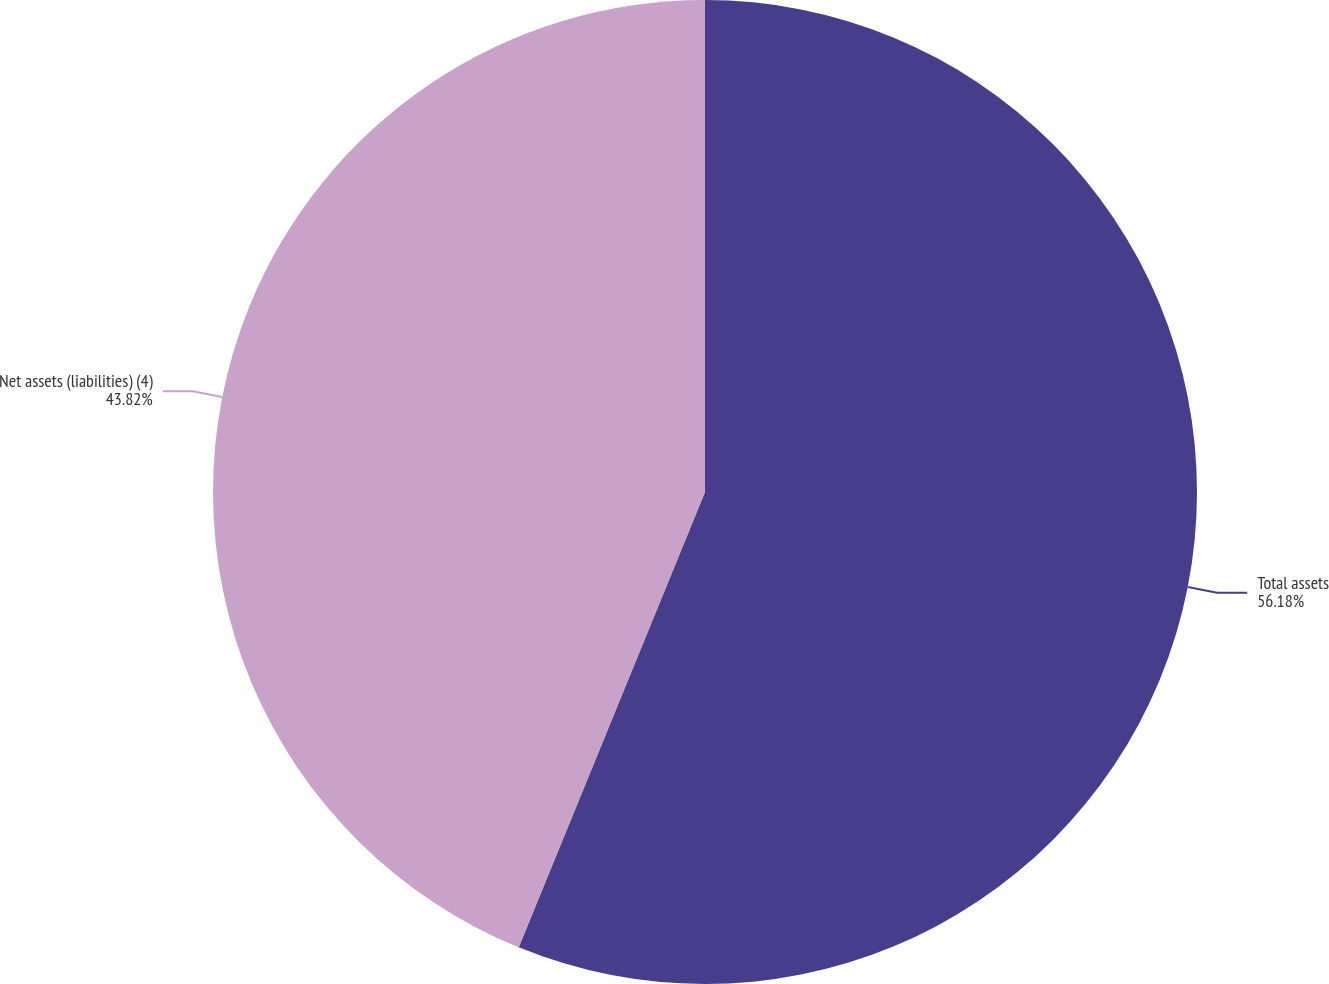Convert chart. <chart><loc_0><loc_0><loc_500><loc_500><pie_chart><fcel>Total assets<fcel>Net assets (liabilities) (4)<nl><fcel>56.18%<fcel>43.82%<nl></chart> 